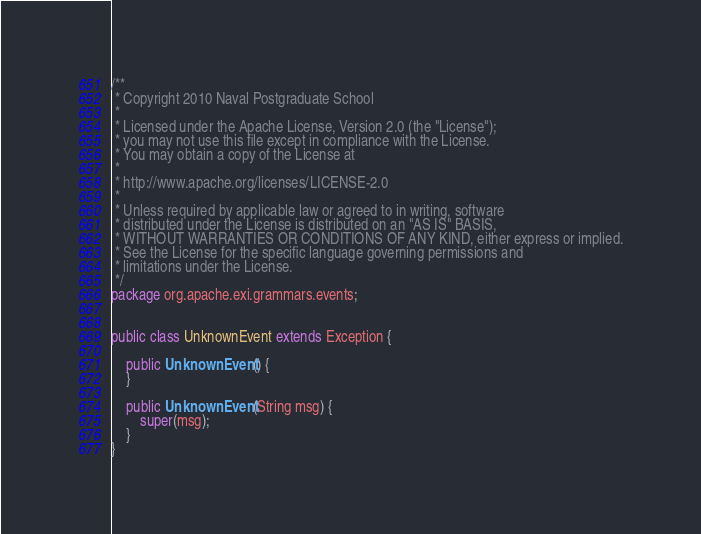Convert code to text. <code><loc_0><loc_0><loc_500><loc_500><_Java_>/**
 * Copyright 2010 Naval Postgraduate School
 *
 * Licensed under the Apache License, Version 2.0 (the "License");
 * you may not use this file except in compliance with the License.
 * You may obtain a copy of the License at
 *
 * http://www.apache.org/licenses/LICENSE-2.0
 *
 * Unless required by applicable law or agreed to in writing, software
 * distributed under the License is distributed on an "AS IS" BASIS,
 * WITHOUT WARRANTIES OR CONDITIONS OF ANY KIND, either express or implied.
 * See the License for the specific language governing permissions and
 * limitations under the License.
 */
package org.apache.exi.grammars.events;


public class UnknownEvent extends Exception {

    public UnknownEvent() {
    }

    public UnknownEvent(String msg) {
        super(msg);
    }
}
</code> 